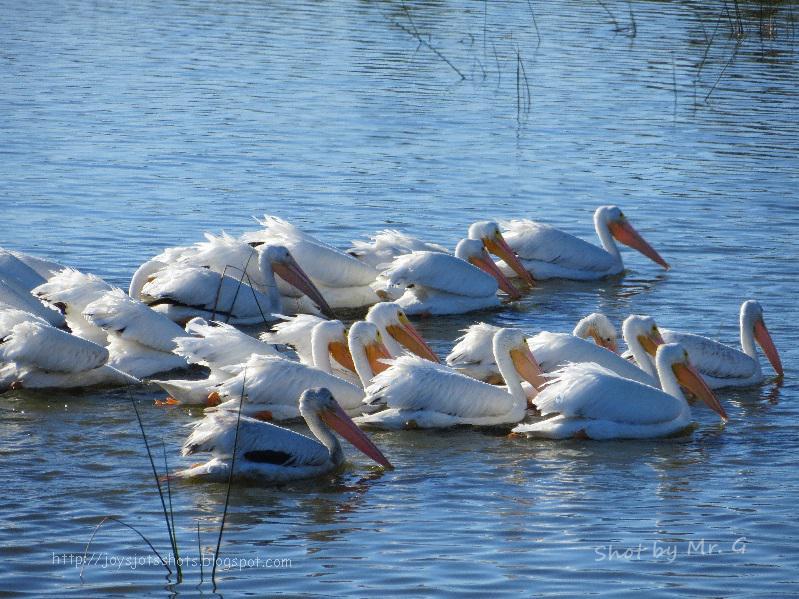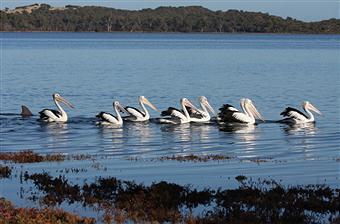The first image is the image on the left, the second image is the image on the right. Evaluate the accuracy of this statement regarding the images: "An image shows exactly one pelican, which has a gaping mouth.". Is it true? Answer yes or no. No. The first image is the image on the left, the second image is the image on the right. Analyze the images presented: Is the assertion "One of the pelicans is opening its mouth wide." valid? Answer yes or no. No. 